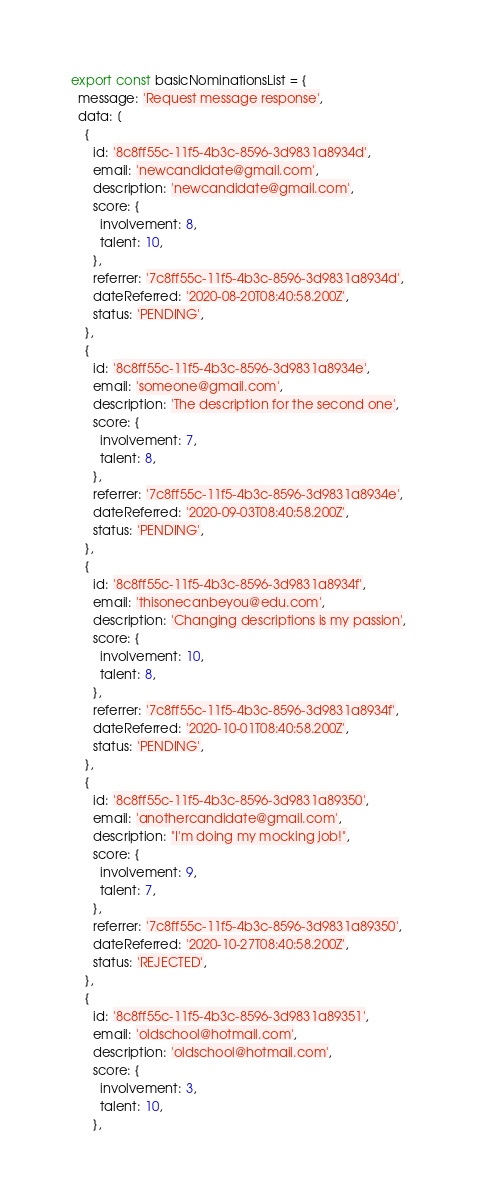Convert code to text. <code><loc_0><loc_0><loc_500><loc_500><_JavaScript_>export const basicNominationsList = {
  message: 'Request message response',
  data: [
    {
      id: '8c8ff55c-11f5-4b3c-8596-3d9831a8934d',
      email: 'newcandidate@gmail.com',
      description: 'newcandidate@gmail.com',
      score: {
        involvement: 8,
        talent: 10,
      },
      referrer: '7c8ff55c-11f5-4b3c-8596-3d9831a8934d',
      dateReferred: '2020-08-20T08:40:58.200Z',
      status: 'PENDING',
    },
    {
      id: '8c8ff55c-11f5-4b3c-8596-3d9831a8934e',
      email: 'someone@gmail.com',
      description: 'The description for the second one',
      score: {
        involvement: 7,
        talent: 8,
      },
      referrer: '7c8ff55c-11f5-4b3c-8596-3d9831a8934e',
      dateReferred: '2020-09-03T08:40:58.200Z',
      status: 'PENDING',
    },
    {
      id: '8c8ff55c-11f5-4b3c-8596-3d9831a8934f',
      email: 'thisonecanbeyou@edu.com',
      description: 'Changing descriptions is my passion',
      score: {
        involvement: 10,
        talent: 8,
      },
      referrer: '7c8ff55c-11f5-4b3c-8596-3d9831a8934f',
      dateReferred: '2020-10-01T08:40:58.200Z',
      status: 'PENDING',
    },
    {
      id: '8c8ff55c-11f5-4b3c-8596-3d9831a89350',
      email: 'anothercandidate@gmail.com',
      description: "I'm doing my mocking job!",
      score: {
        involvement: 9,
        talent: 7,
      },
      referrer: '7c8ff55c-11f5-4b3c-8596-3d9831a89350',
      dateReferred: '2020-10-27T08:40:58.200Z',
      status: 'REJECTED',
    },
    {
      id: '8c8ff55c-11f5-4b3c-8596-3d9831a89351',
      email: 'oldschool@hotmail.com',
      description: 'oldschool@hotmail.com',
      score: {
        involvement: 3,
        talent: 10,
      },</code> 